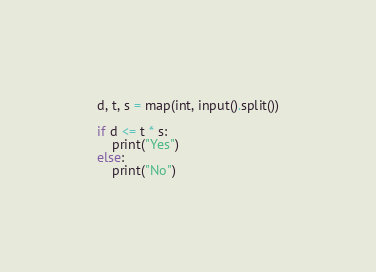Convert code to text. <code><loc_0><loc_0><loc_500><loc_500><_Python_>d, t, s = map(int, input().split())

if d <= t * s:
    print("Yes")
else:
    print("No")</code> 